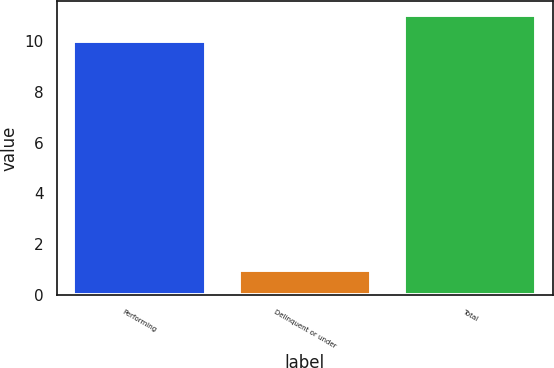Convert chart to OTSL. <chart><loc_0><loc_0><loc_500><loc_500><bar_chart><fcel>Performing<fcel>Delinquent or under<fcel>Total<nl><fcel>10<fcel>1<fcel>11<nl></chart> 